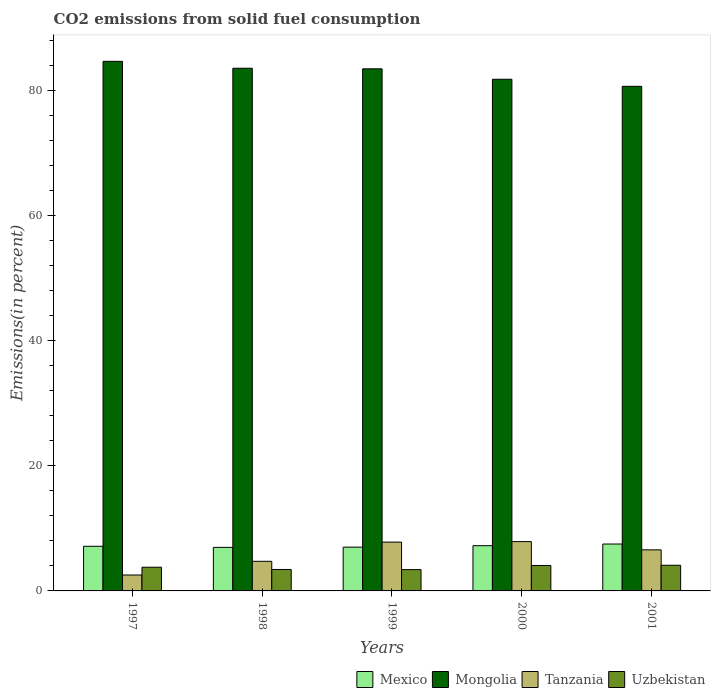How many bars are there on the 3rd tick from the left?
Provide a short and direct response. 4. What is the total CO2 emitted in Tanzania in 2001?
Make the answer very short. 6.57. Across all years, what is the maximum total CO2 emitted in Mongolia?
Your answer should be very brief. 84.64. Across all years, what is the minimum total CO2 emitted in Mexico?
Your response must be concise. 6.96. In which year was the total CO2 emitted in Mexico minimum?
Make the answer very short. 1998. What is the total total CO2 emitted in Mongolia in the graph?
Provide a succinct answer. 414.06. What is the difference between the total CO2 emitted in Mexico in 1998 and that in 2001?
Your answer should be very brief. -0.54. What is the difference between the total CO2 emitted in Mexico in 1998 and the total CO2 emitted in Mongolia in 1999?
Provide a succinct answer. -76.49. What is the average total CO2 emitted in Uzbekistan per year?
Provide a succinct answer. 3.76. In the year 1999, what is the difference between the total CO2 emitted in Tanzania and total CO2 emitted in Uzbekistan?
Keep it short and to the point. 4.4. What is the ratio of the total CO2 emitted in Mongolia in 1999 to that in 2001?
Provide a short and direct response. 1.03. What is the difference between the highest and the second highest total CO2 emitted in Tanzania?
Give a very brief answer. 0.08. What is the difference between the highest and the lowest total CO2 emitted in Uzbekistan?
Offer a terse response. 0.7. Is it the case that in every year, the sum of the total CO2 emitted in Mongolia and total CO2 emitted in Tanzania is greater than the sum of total CO2 emitted in Mexico and total CO2 emitted in Uzbekistan?
Provide a succinct answer. Yes. What does the 2nd bar from the right in 1998 represents?
Provide a short and direct response. Tanzania. Is it the case that in every year, the sum of the total CO2 emitted in Uzbekistan and total CO2 emitted in Mexico is greater than the total CO2 emitted in Tanzania?
Make the answer very short. Yes. What is the difference between two consecutive major ticks on the Y-axis?
Give a very brief answer. 20. Are the values on the major ticks of Y-axis written in scientific E-notation?
Make the answer very short. No. What is the title of the graph?
Keep it short and to the point. CO2 emissions from solid fuel consumption. Does "Macao" appear as one of the legend labels in the graph?
Provide a short and direct response. No. What is the label or title of the Y-axis?
Provide a succinct answer. Emissions(in percent). What is the Emissions(in percent) in Mexico in 1997?
Give a very brief answer. 7.14. What is the Emissions(in percent) of Mongolia in 1997?
Your answer should be very brief. 84.64. What is the Emissions(in percent) in Tanzania in 1997?
Provide a succinct answer. 2.54. What is the Emissions(in percent) in Uzbekistan in 1997?
Provide a short and direct response. 3.79. What is the Emissions(in percent) in Mexico in 1998?
Provide a succinct answer. 6.96. What is the Emissions(in percent) in Mongolia in 1998?
Offer a terse response. 83.54. What is the Emissions(in percent) of Tanzania in 1998?
Your response must be concise. 4.73. What is the Emissions(in percent) in Uzbekistan in 1998?
Your response must be concise. 3.43. What is the Emissions(in percent) in Mexico in 1999?
Offer a terse response. 7. What is the Emissions(in percent) of Mongolia in 1999?
Your response must be concise. 83.45. What is the Emissions(in percent) of Tanzania in 1999?
Ensure brevity in your answer.  7.8. What is the Emissions(in percent) of Uzbekistan in 1999?
Offer a very short reply. 3.41. What is the Emissions(in percent) in Mexico in 2000?
Your answer should be compact. 7.23. What is the Emissions(in percent) in Mongolia in 2000?
Keep it short and to the point. 81.78. What is the Emissions(in percent) in Tanzania in 2000?
Your answer should be very brief. 7.88. What is the Emissions(in percent) of Uzbekistan in 2000?
Your response must be concise. 4.07. What is the Emissions(in percent) of Mexico in 2001?
Give a very brief answer. 7.5. What is the Emissions(in percent) in Mongolia in 2001?
Make the answer very short. 80.65. What is the Emissions(in percent) in Tanzania in 2001?
Offer a terse response. 6.57. What is the Emissions(in percent) of Uzbekistan in 2001?
Ensure brevity in your answer.  4.1. Across all years, what is the maximum Emissions(in percent) of Mexico?
Ensure brevity in your answer.  7.5. Across all years, what is the maximum Emissions(in percent) in Mongolia?
Provide a short and direct response. 84.64. Across all years, what is the maximum Emissions(in percent) of Tanzania?
Provide a succinct answer. 7.88. Across all years, what is the maximum Emissions(in percent) in Uzbekistan?
Give a very brief answer. 4.1. Across all years, what is the minimum Emissions(in percent) in Mexico?
Your answer should be very brief. 6.96. Across all years, what is the minimum Emissions(in percent) in Mongolia?
Offer a very short reply. 80.65. Across all years, what is the minimum Emissions(in percent) in Tanzania?
Provide a short and direct response. 2.54. Across all years, what is the minimum Emissions(in percent) of Uzbekistan?
Your response must be concise. 3.41. What is the total Emissions(in percent) in Mexico in the graph?
Keep it short and to the point. 35.82. What is the total Emissions(in percent) of Mongolia in the graph?
Your response must be concise. 414.06. What is the total Emissions(in percent) in Tanzania in the graph?
Provide a succinct answer. 29.53. What is the total Emissions(in percent) of Uzbekistan in the graph?
Offer a very short reply. 18.79. What is the difference between the Emissions(in percent) in Mexico in 1997 and that in 1998?
Ensure brevity in your answer.  0.18. What is the difference between the Emissions(in percent) in Mongolia in 1997 and that in 1998?
Ensure brevity in your answer.  1.1. What is the difference between the Emissions(in percent) in Tanzania in 1997 and that in 1998?
Make the answer very short. -2.19. What is the difference between the Emissions(in percent) of Uzbekistan in 1997 and that in 1998?
Your answer should be compact. 0.36. What is the difference between the Emissions(in percent) in Mexico in 1997 and that in 1999?
Your response must be concise. 0.14. What is the difference between the Emissions(in percent) in Mongolia in 1997 and that in 1999?
Ensure brevity in your answer.  1.19. What is the difference between the Emissions(in percent) of Tanzania in 1997 and that in 1999?
Provide a short and direct response. -5.26. What is the difference between the Emissions(in percent) in Uzbekistan in 1997 and that in 1999?
Give a very brief answer. 0.38. What is the difference between the Emissions(in percent) of Mexico in 1997 and that in 2000?
Ensure brevity in your answer.  -0.09. What is the difference between the Emissions(in percent) of Mongolia in 1997 and that in 2000?
Offer a terse response. 2.86. What is the difference between the Emissions(in percent) in Tanzania in 1997 and that in 2000?
Keep it short and to the point. -5.34. What is the difference between the Emissions(in percent) in Uzbekistan in 1997 and that in 2000?
Give a very brief answer. -0.28. What is the difference between the Emissions(in percent) of Mexico in 1997 and that in 2001?
Make the answer very short. -0.36. What is the difference between the Emissions(in percent) in Mongolia in 1997 and that in 2001?
Your answer should be compact. 3.99. What is the difference between the Emissions(in percent) of Tanzania in 1997 and that in 2001?
Make the answer very short. -4.02. What is the difference between the Emissions(in percent) of Uzbekistan in 1997 and that in 2001?
Your answer should be very brief. -0.31. What is the difference between the Emissions(in percent) in Mexico in 1998 and that in 1999?
Your response must be concise. -0.04. What is the difference between the Emissions(in percent) of Mongolia in 1998 and that in 1999?
Your answer should be compact. 0.09. What is the difference between the Emissions(in percent) of Tanzania in 1998 and that in 1999?
Provide a succinct answer. -3.07. What is the difference between the Emissions(in percent) of Uzbekistan in 1998 and that in 1999?
Keep it short and to the point. 0.02. What is the difference between the Emissions(in percent) in Mexico in 1998 and that in 2000?
Keep it short and to the point. -0.27. What is the difference between the Emissions(in percent) in Mongolia in 1998 and that in 2000?
Make the answer very short. 1.76. What is the difference between the Emissions(in percent) in Tanzania in 1998 and that in 2000?
Keep it short and to the point. -3.15. What is the difference between the Emissions(in percent) in Uzbekistan in 1998 and that in 2000?
Provide a short and direct response. -0.64. What is the difference between the Emissions(in percent) in Mexico in 1998 and that in 2001?
Your answer should be compact. -0.54. What is the difference between the Emissions(in percent) in Mongolia in 1998 and that in 2001?
Keep it short and to the point. 2.89. What is the difference between the Emissions(in percent) of Tanzania in 1998 and that in 2001?
Offer a very short reply. -1.83. What is the difference between the Emissions(in percent) in Uzbekistan in 1998 and that in 2001?
Ensure brevity in your answer.  -0.68. What is the difference between the Emissions(in percent) of Mexico in 1999 and that in 2000?
Your answer should be compact. -0.23. What is the difference between the Emissions(in percent) in Mongolia in 1999 and that in 2000?
Make the answer very short. 1.67. What is the difference between the Emissions(in percent) in Tanzania in 1999 and that in 2000?
Ensure brevity in your answer.  -0.08. What is the difference between the Emissions(in percent) in Uzbekistan in 1999 and that in 2000?
Provide a short and direct response. -0.66. What is the difference between the Emissions(in percent) in Mexico in 1999 and that in 2001?
Make the answer very short. -0.5. What is the difference between the Emissions(in percent) of Mongolia in 1999 and that in 2001?
Provide a short and direct response. 2.8. What is the difference between the Emissions(in percent) in Tanzania in 1999 and that in 2001?
Your answer should be very brief. 1.24. What is the difference between the Emissions(in percent) of Uzbekistan in 1999 and that in 2001?
Make the answer very short. -0.7. What is the difference between the Emissions(in percent) of Mexico in 2000 and that in 2001?
Your answer should be compact. -0.27. What is the difference between the Emissions(in percent) of Mongolia in 2000 and that in 2001?
Make the answer very short. 1.13. What is the difference between the Emissions(in percent) of Tanzania in 2000 and that in 2001?
Your answer should be very brief. 1.32. What is the difference between the Emissions(in percent) in Uzbekistan in 2000 and that in 2001?
Provide a succinct answer. -0.04. What is the difference between the Emissions(in percent) in Mexico in 1997 and the Emissions(in percent) in Mongolia in 1998?
Ensure brevity in your answer.  -76.4. What is the difference between the Emissions(in percent) in Mexico in 1997 and the Emissions(in percent) in Tanzania in 1998?
Provide a succinct answer. 2.4. What is the difference between the Emissions(in percent) in Mexico in 1997 and the Emissions(in percent) in Uzbekistan in 1998?
Keep it short and to the point. 3.71. What is the difference between the Emissions(in percent) of Mongolia in 1997 and the Emissions(in percent) of Tanzania in 1998?
Your answer should be compact. 79.91. What is the difference between the Emissions(in percent) in Mongolia in 1997 and the Emissions(in percent) in Uzbekistan in 1998?
Provide a short and direct response. 81.21. What is the difference between the Emissions(in percent) of Tanzania in 1997 and the Emissions(in percent) of Uzbekistan in 1998?
Provide a short and direct response. -0.88. What is the difference between the Emissions(in percent) of Mexico in 1997 and the Emissions(in percent) of Mongolia in 1999?
Make the answer very short. -76.31. What is the difference between the Emissions(in percent) of Mexico in 1997 and the Emissions(in percent) of Tanzania in 1999?
Offer a very short reply. -0.67. What is the difference between the Emissions(in percent) of Mexico in 1997 and the Emissions(in percent) of Uzbekistan in 1999?
Provide a succinct answer. 3.73. What is the difference between the Emissions(in percent) in Mongolia in 1997 and the Emissions(in percent) in Tanzania in 1999?
Make the answer very short. 76.84. What is the difference between the Emissions(in percent) in Mongolia in 1997 and the Emissions(in percent) in Uzbekistan in 1999?
Ensure brevity in your answer.  81.23. What is the difference between the Emissions(in percent) of Tanzania in 1997 and the Emissions(in percent) of Uzbekistan in 1999?
Your answer should be very brief. -0.86. What is the difference between the Emissions(in percent) of Mexico in 1997 and the Emissions(in percent) of Mongolia in 2000?
Offer a very short reply. -74.64. What is the difference between the Emissions(in percent) in Mexico in 1997 and the Emissions(in percent) in Tanzania in 2000?
Offer a terse response. -0.75. What is the difference between the Emissions(in percent) in Mexico in 1997 and the Emissions(in percent) in Uzbekistan in 2000?
Provide a succinct answer. 3.07. What is the difference between the Emissions(in percent) of Mongolia in 1997 and the Emissions(in percent) of Tanzania in 2000?
Provide a succinct answer. 76.76. What is the difference between the Emissions(in percent) in Mongolia in 1997 and the Emissions(in percent) in Uzbekistan in 2000?
Give a very brief answer. 80.58. What is the difference between the Emissions(in percent) of Tanzania in 1997 and the Emissions(in percent) of Uzbekistan in 2000?
Offer a terse response. -1.52. What is the difference between the Emissions(in percent) of Mexico in 1997 and the Emissions(in percent) of Mongolia in 2001?
Make the answer very short. -73.52. What is the difference between the Emissions(in percent) of Mexico in 1997 and the Emissions(in percent) of Tanzania in 2001?
Your answer should be compact. 0.57. What is the difference between the Emissions(in percent) of Mexico in 1997 and the Emissions(in percent) of Uzbekistan in 2001?
Offer a terse response. 3.03. What is the difference between the Emissions(in percent) in Mongolia in 1997 and the Emissions(in percent) in Tanzania in 2001?
Your answer should be compact. 78.08. What is the difference between the Emissions(in percent) of Mongolia in 1997 and the Emissions(in percent) of Uzbekistan in 2001?
Provide a short and direct response. 80.54. What is the difference between the Emissions(in percent) of Tanzania in 1997 and the Emissions(in percent) of Uzbekistan in 2001?
Ensure brevity in your answer.  -1.56. What is the difference between the Emissions(in percent) of Mexico in 1998 and the Emissions(in percent) of Mongolia in 1999?
Make the answer very short. -76.49. What is the difference between the Emissions(in percent) in Mexico in 1998 and the Emissions(in percent) in Tanzania in 1999?
Your response must be concise. -0.84. What is the difference between the Emissions(in percent) in Mexico in 1998 and the Emissions(in percent) in Uzbekistan in 1999?
Provide a short and direct response. 3.55. What is the difference between the Emissions(in percent) in Mongolia in 1998 and the Emissions(in percent) in Tanzania in 1999?
Keep it short and to the point. 75.74. What is the difference between the Emissions(in percent) of Mongolia in 1998 and the Emissions(in percent) of Uzbekistan in 1999?
Provide a short and direct response. 80.13. What is the difference between the Emissions(in percent) of Tanzania in 1998 and the Emissions(in percent) of Uzbekistan in 1999?
Keep it short and to the point. 1.33. What is the difference between the Emissions(in percent) in Mexico in 1998 and the Emissions(in percent) in Mongolia in 2000?
Keep it short and to the point. -74.82. What is the difference between the Emissions(in percent) in Mexico in 1998 and the Emissions(in percent) in Tanzania in 2000?
Your answer should be compact. -0.92. What is the difference between the Emissions(in percent) of Mexico in 1998 and the Emissions(in percent) of Uzbekistan in 2000?
Keep it short and to the point. 2.9. What is the difference between the Emissions(in percent) of Mongolia in 1998 and the Emissions(in percent) of Tanzania in 2000?
Provide a succinct answer. 75.66. What is the difference between the Emissions(in percent) of Mongolia in 1998 and the Emissions(in percent) of Uzbekistan in 2000?
Ensure brevity in your answer.  79.47. What is the difference between the Emissions(in percent) of Tanzania in 1998 and the Emissions(in percent) of Uzbekistan in 2000?
Your answer should be very brief. 0.67. What is the difference between the Emissions(in percent) in Mexico in 1998 and the Emissions(in percent) in Mongolia in 2001?
Offer a terse response. -73.69. What is the difference between the Emissions(in percent) of Mexico in 1998 and the Emissions(in percent) of Tanzania in 2001?
Ensure brevity in your answer.  0.4. What is the difference between the Emissions(in percent) of Mexico in 1998 and the Emissions(in percent) of Uzbekistan in 2001?
Ensure brevity in your answer.  2.86. What is the difference between the Emissions(in percent) of Mongolia in 1998 and the Emissions(in percent) of Tanzania in 2001?
Ensure brevity in your answer.  76.97. What is the difference between the Emissions(in percent) in Mongolia in 1998 and the Emissions(in percent) in Uzbekistan in 2001?
Offer a terse response. 79.44. What is the difference between the Emissions(in percent) in Tanzania in 1998 and the Emissions(in percent) in Uzbekistan in 2001?
Your answer should be very brief. 0.63. What is the difference between the Emissions(in percent) of Mexico in 1999 and the Emissions(in percent) of Mongolia in 2000?
Provide a short and direct response. -74.78. What is the difference between the Emissions(in percent) of Mexico in 1999 and the Emissions(in percent) of Tanzania in 2000?
Provide a succinct answer. -0.89. What is the difference between the Emissions(in percent) in Mexico in 1999 and the Emissions(in percent) in Uzbekistan in 2000?
Give a very brief answer. 2.93. What is the difference between the Emissions(in percent) of Mongolia in 1999 and the Emissions(in percent) of Tanzania in 2000?
Make the answer very short. 75.56. What is the difference between the Emissions(in percent) in Mongolia in 1999 and the Emissions(in percent) in Uzbekistan in 2000?
Your answer should be compact. 79.38. What is the difference between the Emissions(in percent) of Tanzania in 1999 and the Emissions(in percent) of Uzbekistan in 2000?
Offer a very short reply. 3.74. What is the difference between the Emissions(in percent) of Mexico in 1999 and the Emissions(in percent) of Mongolia in 2001?
Ensure brevity in your answer.  -73.65. What is the difference between the Emissions(in percent) of Mexico in 1999 and the Emissions(in percent) of Tanzania in 2001?
Keep it short and to the point. 0.43. What is the difference between the Emissions(in percent) in Mexico in 1999 and the Emissions(in percent) in Uzbekistan in 2001?
Your answer should be compact. 2.9. What is the difference between the Emissions(in percent) of Mongolia in 1999 and the Emissions(in percent) of Tanzania in 2001?
Give a very brief answer. 76.88. What is the difference between the Emissions(in percent) in Mongolia in 1999 and the Emissions(in percent) in Uzbekistan in 2001?
Your answer should be compact. 79.34. What is the difference between the Emissions(in percent) of Tanzania in 1999 and the Emissions(in percent) of Uzbekistan in 2001?
Offer a terse response. 3.7. What is the difference between the Emissions(in percent) in Mexico in 2000 and the Emissions(in percent) in Mongolia in 2001?
Your answer should be very brief. -73.42. What is the difference between the Emissions(in percent) in Mexico in 2000 and the Emissions(in percent) in Tanzania in 2001?
Keep it short and to the point. 0.67. What is the difference between the Emissions(in percent) of Mexico in 2000 and the Emissions(in percent) of Uzbekistan in 2001?
Make the answer very short. 3.13. What is the difference between the Emissions(in percent) of Mongolia in 2000 and the Emissions(in percent) of Tanzania in 2001?
Keep it short and to the point. 75.21. What is the difference between the Emissions(in percent) of Mongolia in 2000 and the Emissions(in percent) of Uzbekistan in 2001?
Keep it short and to the point. 77.68. What is the difference between the Emissions(in percent) of Tanzania in 2000 and the Emissions(in percent) of Uzbekistan in 2001?
Give a very brief answer. 3.78. What is the average Emissions(in percent) of Mexico per year?
Your answer should be compact. 7.16. What is the average Emissions(in percent) of Mongolia per year?
Your answer should be compact. 82.81. What is the average Emissions(in percent) in Tanzania per year?
Ensure brevity in your answer.  5.91. What is the average Emissions(in percent) in Uzbekistan per year?
Your response must be concise. 3.76. In the year 1997, what is the difference between the Emissions(in percent) in Mexico and Emissions(in percent) in Mongolia?
Offer a very short reply. -77.51. In the year 1997, what is the difference between the Emissions(in percent) in Mexico and Emissions(in percent) in Tanzania?
Offer a terse response. 4.59. In the year 1997, what is the difference between the Emissions(in percent) of Mexico and Emissions(in percent) of Uzbekistan?
Keep it short and to the point. 3.35. In the year 1997, what is the difference between the Emissions(in percent) in Mongolia and Emissions(in percent) in Tanzania?
Provide a succinct answer. 82.1. In the year 1997, what is the difference between the Emissions(in percent) in Mongolia and Emissions(in percent) in Uzbekistan?
Your response must be concise. 80.85. In the year 1997, what is the difference between the Emissions(in percent) in Tanzania and Emissions(in percent) in Uzbekistan?
Offer a very short reply. -1.24. In the year 1998, what is the difference between the Emissions(in percent) of Mexico and Emissions(in percent) of Mongolia?
Keep it short and to the point. -76.58. In the year 1998, what is the difference between the Emissions(in percent) in Mexico and Emissions(in percent) in Tanzania?
Your response must be concise. 2.23. In the year 1998, what is the difference between the Emissions(in percent) of Mexico and Emissions(in percent) of Uzbekistan?
Keep it short and to the point. 3.53. In the year 1998, what is the difference between the Emissions(in percent) in Mongolia and Emissions(in percent) in Tanzania?
Provide a succinct answer. 78.8. In the year 1998, what is the difference between the Emissions(in percent) in Mongolia and Emissions(in percent) in Uzbekistan?
Offer a very short reply. 80.11. In the year 1998, what is the difference between the Emissions(in percent) of Tanzania and Emissions(in percent) of Uzbekistan?
Your answer should be very brief. 1.31. In the year 1999, what is the difference between the Emissions(in percent) in Mexico and Emissions(in percent) in Mongolia?
Offer a very short reply. -76.45. In the year 1999, what is the difference between the Emissions(in percent) of Mexico and Emissions(in percent) of Tanzania?
Ensure brevity in your answer.  -0.81. In the year 1999, what is the difference between the Emissions(in percent) of Mexico and Emissions(in percent) of Uzbekistan?
Offer a very short reply. 3.59. In the year 1999, what is the difference between the Emissions(in percent) in Mongolia and Emissions(in percent) in Tanzania?
Your response must be concise. 75.64. In the year 1999, what is the difference between the Emissions(in percent) of Mongolia and Emissions(in percent) of Uzbekistan?
Keep it short and to the point. 80.04. In the year 1999, what is the difference between the Emissions(in percent) of Tanzania and Emissions(in percent) of Uzbekistan?
Your answer should be compact. 4.4. In the year 2000, what is the difference between the Emissions(in percent) of Mexico and Emissions(in percent) of Mongolia?
Provide a short and direct response. -74.55. In the year 2000, what is the difference between the Emissions(in percent) of Mexico and Emissions(in percent) of Tanzania?
Provide a succinct answer. -0.65. In the year 2000, what is the difference between the Emissions(in percent) of Mexico and Emissions(in percent) of Uzbekistan?
Give a very brief answer. 3.17. In the year 2000, what is the difference between the Emissions(in percent) of Mongolia and Emissions(in percent) of Tanzania?
Offer a very short reply. 73.89. In the year 2000, what is the difference between the Emissions(in percent) of Mongolia and Emissions(in percent) of Uzbekistan?
Offer a very short reply. 77.71. In the year 2000, what is the difference between the Emissions(in percent) of Tanzania and Emissions(in percent) of Uzbekistan?
Your answer should be compact. 3.82. In the year 2001, what is the difference between the Emissions(in percent) in Mexico and Emissions(in percent) in Mongolia?
Provide a short and direct response. -73.16. In the year 2001, what is the difference between the Emissions(in percent) of Mexico and Emissions(in percent) of Tanzania?
Ensure brevity in your answer.  0.93. In the year 2001, what is the difference between the Emissions(in percent) in Mexico and Emissions(in percent) in Uzbekistan?
Provide a succinct answer. 3.39. In the year 2001, what is the difference between the Emissions(in percent) in Mongolia and Emissions(in percent) in Tanzania?
Your answer should be very brief. 74.09. In the year 2001, what is the difference between the Emissions(in percent) in Mongolia and Emissions(in percent) in Uzbekistan?
Your answer should be compact. 76.55. In the year 2001, what is the difference between the Emissions(in percent) in Tanzania and Emissions(in percent) in Uzbekistan?
Make the answer very short. 2.46. What is the ratio of the Emissions(in percent) of Mexico in 1997 to that in 1998?
Your answer should be very brief. 1.03. What is the ratio of the Emissions(in percent) of Mongolia in 1997 to that in 1998?
Offer a very short reply. 1.01. What is the ratio of the Emissions(in percent) in Tanzania in 1997 to that in 1998?
Provide a succinct answer. 0.54. What is the ratio of the Emissions(in percent) of Uzbekistan in 1997 to that in 1998?
Your answer should be very brief. 1.11. What is the ratio of the Emissions(in percent) of Mexico in 1997 to that in 1999?
Provide a succinct answer. 1.02. What is the ratio of the Emissions(in percent) of Mongolia in 1997 to that in 1999?
Provide a succinct answer. 1.01. What is the ratio of the Emissions(in percent) of Tanzania in 1997 to that in 1999?
Keep it short and to the point. 0.33. What is the ratio of the Emissions(in percent) in Uzbekistan in 1997 to that in 1999?
Offer a terse response. 1.11. What is the ratio of the Emissions(in percent) of Mexico in 1997 to that in 2000?
Keep it short and to the point. 0.99. What is the ratio of the Emissions(in percent) in Mongolia in 1997 to that in 2000?
Your answer should be very brief. 1.03. What is the ratio of the Emissions(in percent) in Tanzania in 1997 to that in 2000?
Your response must be concise. 0.32. What is the ratio of the Emissions(in percent) of Uzbekistan in 1997 to that in 2000?
Offer a very short reply. 0.93. What is the ratio of the Emissions(in percent) in Mexico in 1997 to that in 2001?
Offer a very short reply. 0.95. What is the ratio of the Emissions(in percent) of Mongolia in 1997 to that in 2001?
Your answer should be very brief. 1.05. What is the ratio of the Emissions(in percent) of Tanzania in 1997 to that in 2001?
Offer a terse response. 0.39. What is the ratio of the Emissions(in percent) of Uzbekistan in 1997 to that in 2001?
Your answer should be very brief. 0.92. What is the ratio of the Emissions(in percent) in Mongolia in 1998 to that in 1999?
Ensure brevity in your answer.  1. What is the ratio of the Emissions(in percent) in Tanzania in 1998 to that in 1999?
Give a very brief answer. 0.61. What is the ratio of the Emissions(in percent) in Uzbekistan in 1998 to that in 1999?
Make the answer very short. 1.01. What is the ratio of the Emissions(in percent) in Mexico in 1998 to that in 2000?
Keep it short and to the point. 0.96. What is the ratio of the Emissions(in percent) in Mongolia in 1998 to that in 2000?
Give a very brief answer. 1.02. What is the ratio of the Emissions(in percent) in Tanzania in 1998 to that in 2000?
Your answer should be very brief. 0.6. What is the ratio of the Emissions(in percent) of Uzbekistan in 1998 to that in 2000?
Your response must be concise. 0.84. What is the ratio of the Emissions(in percent) of Mongolia in 1998 to that in 2001?
Offer a very short reply. 1.04. What is the ratio of the Emissions(in percent) of Tanzania in 1998 to that in 2001?
Your response must be concise. 0.72. What is the ratio of the Emissions(in percent) of Uzbekistan in 1998 to that in 2001?
Your answer should be compact. 0.84. What is the ratio of the Emissions(in percent) of Mexico in 1999 to that in 2000?
Your answer should be very brief. 0.97. What is the ratio of the Emissions(in percent) of Mongolia in 1999 to that in 2000?
Provide a succinct answer. 1.02. What is the ratio of the Emissions(in percent) in Uzbekistan in 1999 to that in 2000?
Your response must be concise. 0.84. What is the ratio of the Emissions(in percent) of Mexico in 1999 to that in 2001?
Your response must be concise. 0.93. What is the ratio of the Emissions(in percent) of Mongolia in 1999 to that in 2001?
Offer a very short reply. 1.03. What is the ratio of the Emissions(in percent) in Tanzania in 1999 to that in 2001?
Your answer should be compact. 1.19. What is the ratio of the Emissions(in percent) in Uzbekistan in 1999 to that in 2001?
Your response must be concise. 0.83. What is the ratio of the Emissions(in percent) in Mexico in 2000 to that in 2001?
Give a very brief answer. 0.96. What is the ratio of the Emissions(in percent) in Tanzania in 2000 to that in 2001?
Provide a succinct answer. 1.2. What is the ratio of the Emissions(in percent) of Uzbekistan in 2000 to that in 2001?
Ensure brevity in your answer.  0.99. What is the difference between the highest and the second highest Emissions(in percent) of Mexico?
Provide a succinct answer. 0.27. What is the difference between the highest and the second highest Emissions(in percent) of Mongolia?
Give a very brief answer. 1.1. What is the difference between the highest and the second highest Emissions(in percent) in Tanzania?
Provide a succinct answer. 0.08. What is the difference between the highest and the second highest Emissions(in percent) in Uzbekistan?
Keep it short and to the point. 0.04. What is the difference between the highest and the lowest Emissions(in percent) of Mexico?
Your answer should be very brief. 0.54. What is the difference between the highest and the lowest Emissions(in percent) in Mongolia?
Offer a terse response. 3.99. What is the difference between the highest and the lowest Emissions(in percent) in Tanzania?
Ensure brevity in your answer.  5.34. What is the difference between the highest and the lowest Emissions(in percent) of Uzbekistan?
Your response must be concise. 0.7. 